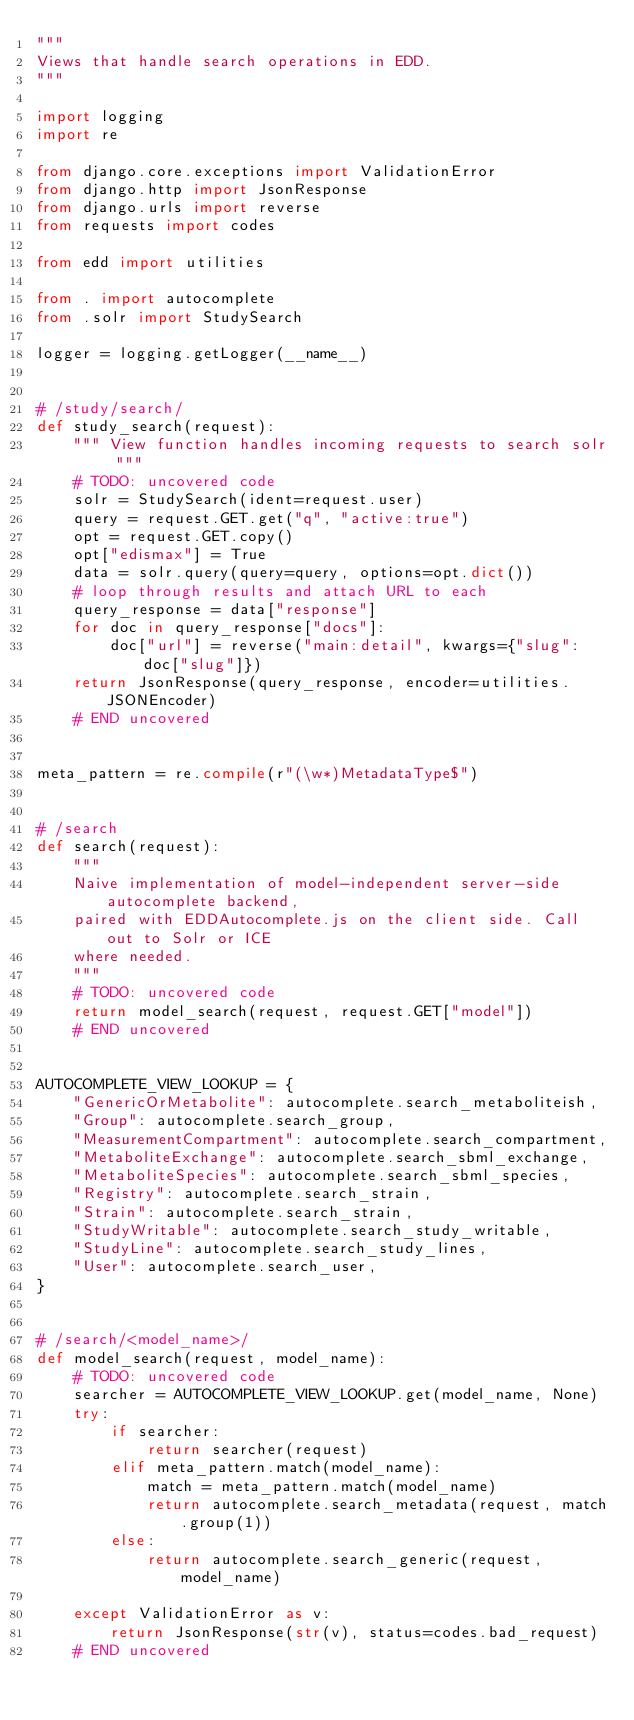<code> <loc_0><loc_0><loc_500><loc_500><_Python_>"""
Views that handle search operations in EDD.
"""

import logging
import re

from django.core.exceptions import ValidationError
from django.http import JsonResponse
from django.urls import reverse
from requests import codes

from edd import utilities

from . import autocomplete
from .solr import StudySearch

logger = logging.getLogger(__name__)


# /study/search/
def study_search(request):
    """ View function handles incoming requests to search solr """
    # TODO: uncovered code
    solr = StudySearch(ident=request.user)
    query = request.GET.get("q", "active:true")
    opt = request.GET.copy()
    opt["edismax"] = True
    data = solr.query(query=query, options=opt.dict())
    # loop through results and attach URL to each
    query_response = data["response"]
    for doc in query_response["docs"]:
        doc["url"] = reverse("main:detail", kwargs={"slug": doc["slug"]})
    return JsonResponse(query_response, encoder=utilities.JSONEncoder)
    # END uncovered


meta_pattern = re.compile(r"(\w*)MetadataType$")


# /search
def search(request):
    """
    Naive implementation of model-independent server-side autocomplete backend,
    paired with EDDAutocomplete.js on the client side. Call out to Solr or ICE
    where needed.
    """
    # TODO: uncovered code
    return model_search(request, request.GET["model"])
    # END uncovered


AUTOCOMPLETE_VIEW_LOOKUP = {
    "GenericOrMetabolite": autocomplete.search_metaboliteish,
    "Group": autocomplete.search_group,
    "MeasurementCompartment": autocomplete.search_compartment,
    "MetaboliteExchange": autocomplete.search_sbml_exchange,
    "MetaboliteSpecies": autocomplete.search_sbml_species,
    "Registry": autocomplete.search_strain,
    "Strain": autocomplete.search_strain,
    "StudyWritable": autocomplete.search_study_writable,
    "StudyLine": autocomplete.search_study_lines,
    "User": autocomplete.search_user,
}


# /search/<model_name>/
def model_search(request, model_name):
    # TODO: uncovered code
    searcher = AUTOCOMPLETE_VIEW_LOOKUP.get(model_name, None)
    try:
        if searcher:
            return searcher(request)
        elif meta_pattern.match(model_name):
            match = meta_pattern.match(model_name)
            return autocomplete.search_metadata(request, match.group(1))
        else:
            return autocomplete.search_generic(request, model_name)

    except ValidationError as v:
        return JsonResponse(str(v), status=codes.bad_request)
    # END uncovered
</code> 